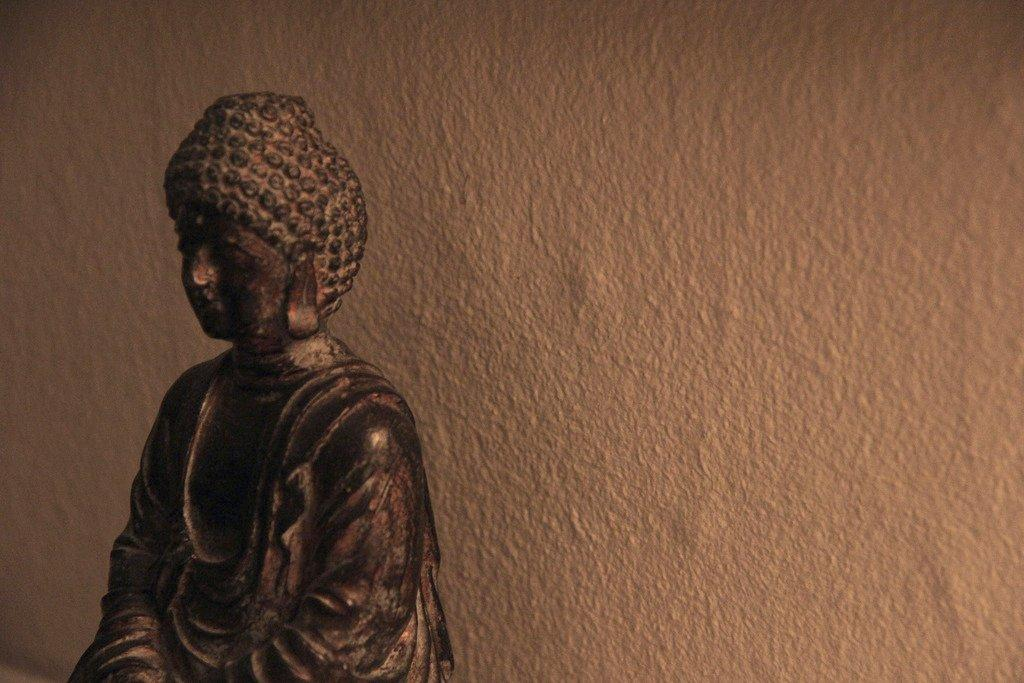What is located on the left side of the image? There is a buddha sculpture on the left side of the image. What can be seen in the background of the image? There is a wall in the background of the image. How many children are visible in the image? There are no children present in the image. What type of print is visible on the wall in the image? There is no print visible on the wall in the image. 